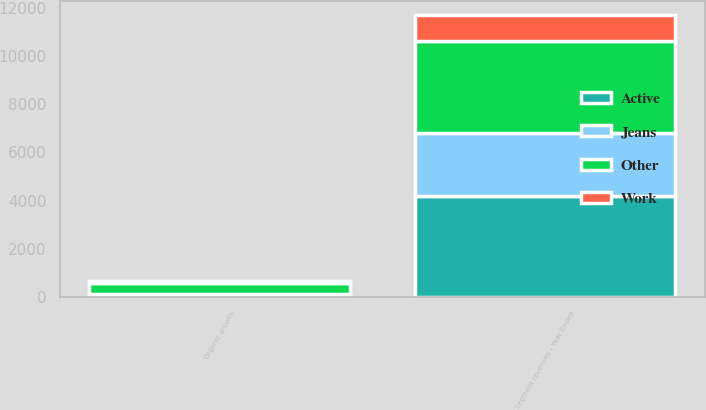Convert chart. <chart><loc_0><loc_0><loc_500><loc_500><stacked_bar_chart><ecel><fcel>Segment revenues - Year Ended<fcel>Organic growth<nl><fcel>Active<fcel>4209<fcel>54.3<nl><fcel>Other<fcel>3791.7<fcel>459.6<nl><fcel>Work<fcel>1099.7<fcel>75.1<nl><fcel>Jeans<fcel>2597.6<fcel>94.9<nl></chart> 